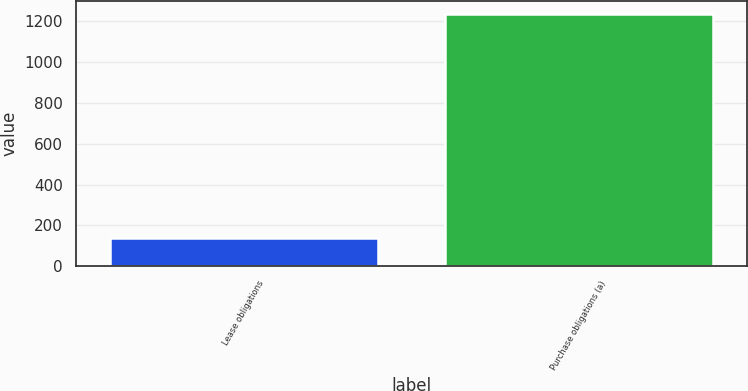Convert chart to OTSL. <chart><loc_0><loc_0><loc_500><loc_500><bar_chart><fcel>Lease obligations<fcel>Purchase obligations (a)<nl><fcel>138<fcel>1238<nl></chart> 